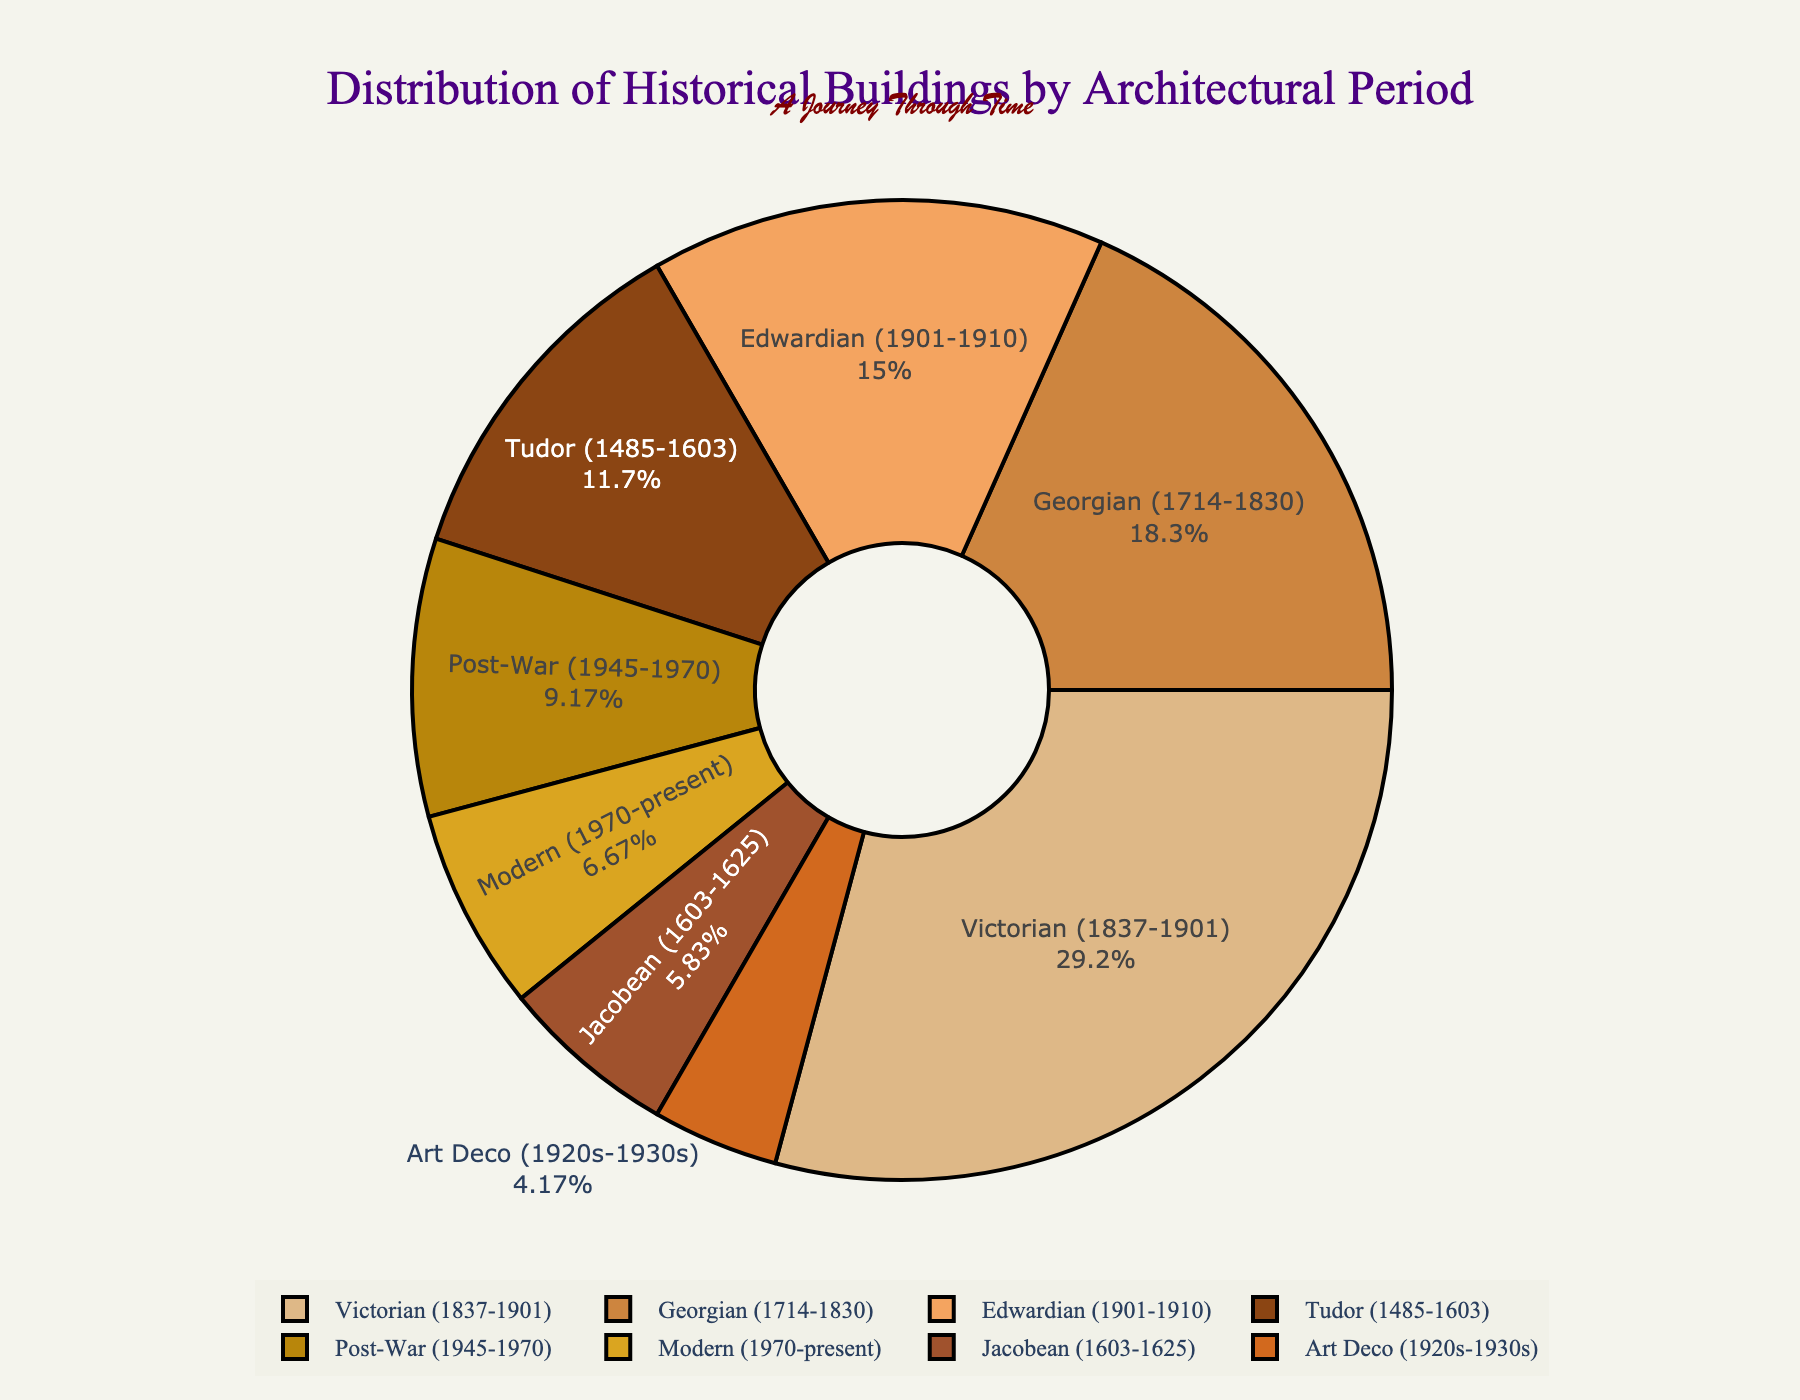Which architectural period has the most historical buildings? By looking at the size of the slices in the pie chart, we can see that the Victorian period has the largest slice, indicating it has the most historical buildings.
Answer: Victorian How many historical buildings are from the Edwardian and Art Deco periods combined? Sum the number of buildings from the Edwardian period (18) and the Art Deco period (5). 18 + 5 = 23
Answer: 23 Which period has fewer historical buildings than the Georgian period but more than the Art Deco period? The Georgian period has 22 buildings, and the Art Deco period has 5 buildings. The periods with buildings less than 22 but more than 5 are Jacobean (7), Post-War (11), and Modern (8). Among these, Jacobean and Modern fulfill the requirement.
Answer: Jacobean and Modern What is the combined percentage of historical buildings from the Tudor and Modern periods? First, find the total number of buildings: 14 (Tudor) + 7 (Jacobean) + 22 (Georgian) + 35 (Victorian) + 18 (Edwardian) + 5 (Art Deco) + 11 (Post-War) + 8 (Modern) = 120. Then, calculate the percentage: ((14 + 8) / 120) * 100 ≈ 18.3%
Answer: 18.3% Which architectural period represents the smallest proportion of historical buildings? Looking at the pie chart, the smallest slice is the one corresponding to the Art Deco period.
Answer: Art Deco How many more historical buildings are from the Victorian period compared to the Modern period? Subtract the number of buildings in the Modern period (8) from the number in the Victorian period (35). 35 - 8 = 27
Answer: 27 What is the visual identifier for the Victorian period in the pie chart? Identify the slice with the largest area and a dark brown color, which corresponds to the Victorian period.
Answer: Large dark brown slice Which architectural period has about one-fourth the number of buildings of the Victorian period? Calculate one-fourth of the Victorian period: 35 / 4 = 8.75. The closest number is 8 (Modern period).
Answer: Modern 